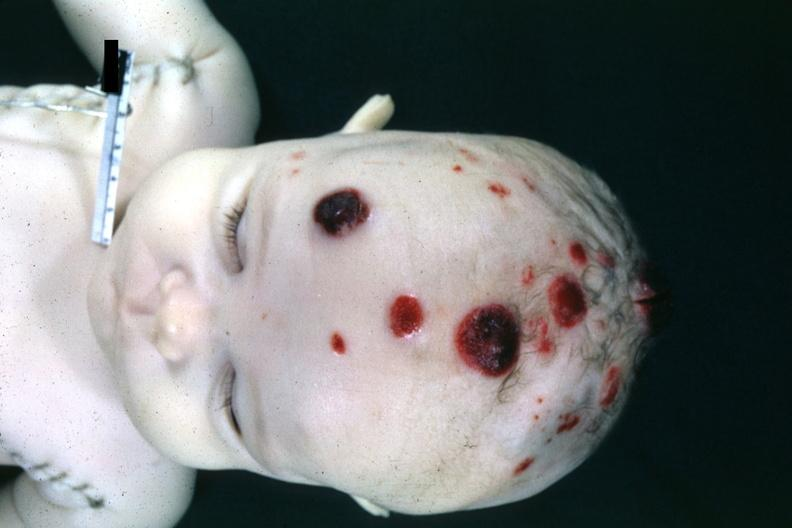what are 4 month old child several slides from this case in?
Answer the question using a single word or phrase. In file 